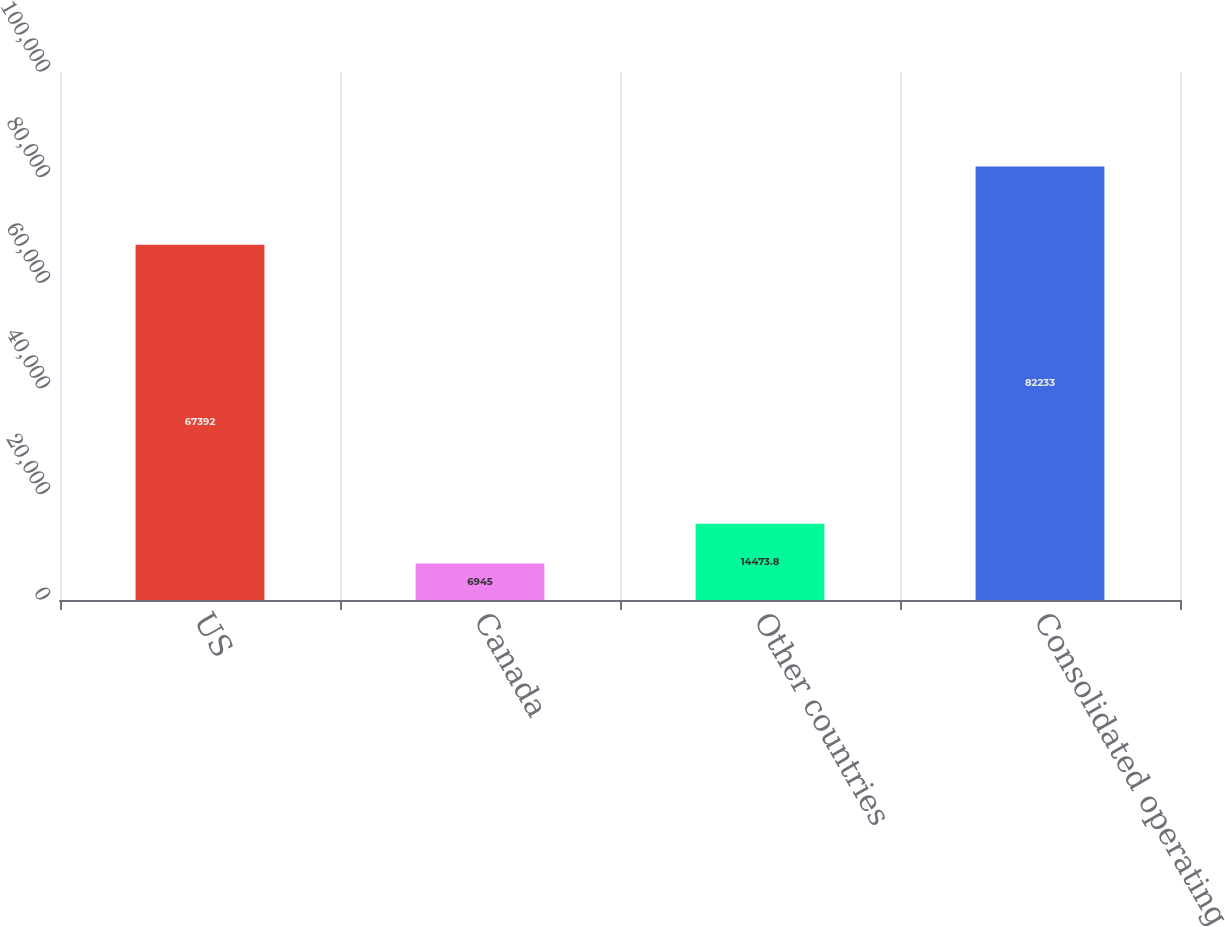Convert chart to OTSL. <chart><loc_0><loc_0><loc_500><loc_500><bar_chart><fcel>US<fcel>Canada<fcel>Other countries<fcel>Consolidated operating<nl><fcel>67392<fcel>6945<fcel>14473.8<fcel>82233<nl></chart> 